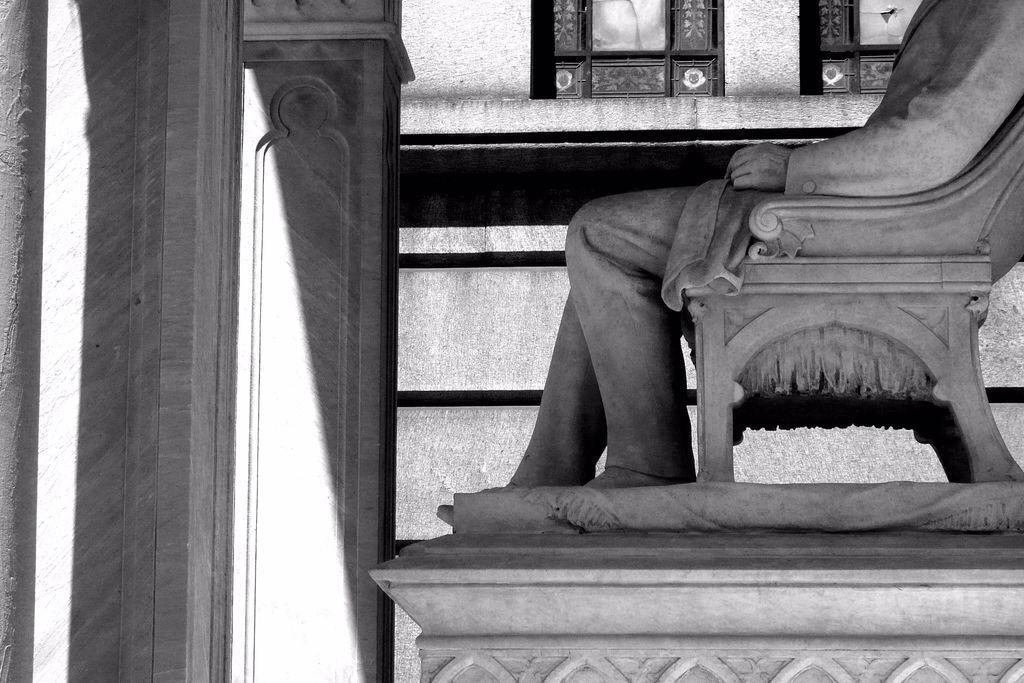Could you give a brief overview of what you see in this image? In this image I see a statue of a person who is sitting on a chair. In the background I see the wall. 